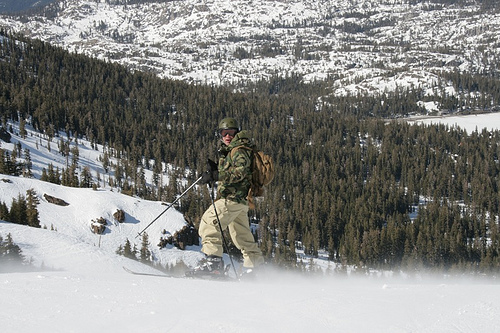<image>What is the location where the man is skiing? It is unknown where the man is skiing. What is the location where the man is skiing? I don't know the location where the man is skiing. It can be in the mountains, Greenland, Colorado, or any other mountainous area. 